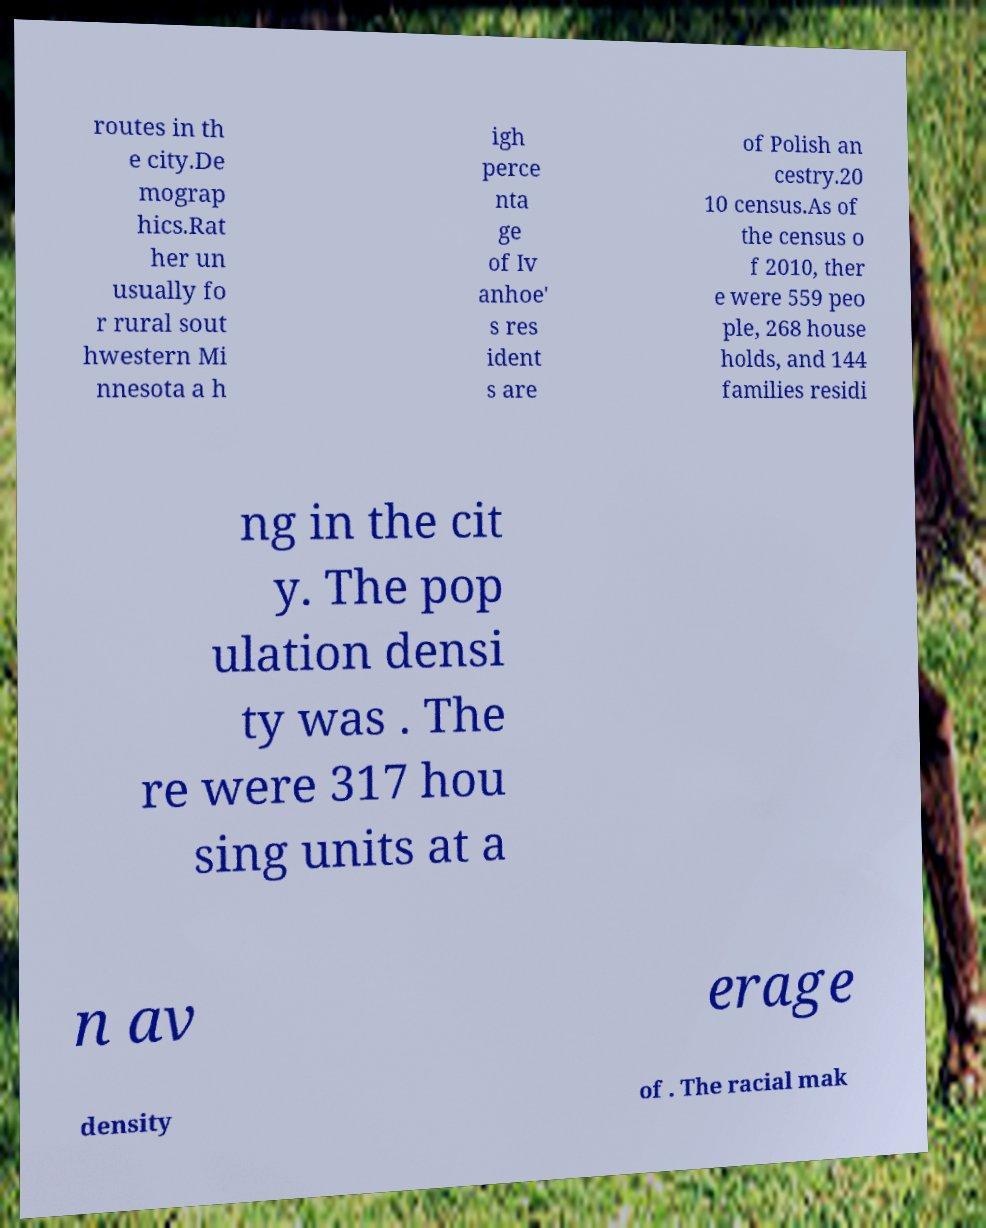I need the written content from this picture converted into text. Can you do that? routes in th e city.De mograp hics.Rat her un usually fo r rural sout hwestern Mi nnesota a h igh perce nta ge of Iv anhoe' s res ident s are of Polish an cestry.20 10 census.As of the census o f 2010, ther e were 559 peo ple, 268 house holds, and 144 families residi ng in the cit y. The pop ulation densi ty was . The re were 317 hou sing units at a n av erage density of . The racial mak 